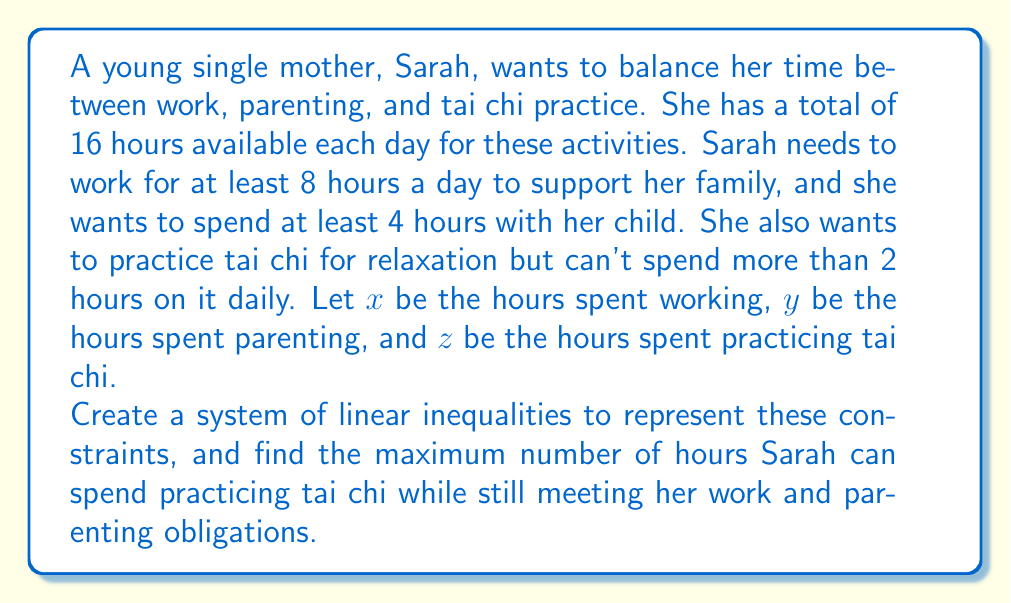Could you help me with this problem? Let's approach this problem step by step:

1. First, we need to set up the system of linear inequalities based on the given information:

   a) Total available time: $x + y + z = 16$
   b) Minimum work time: $x \geq 8$
   c) Minimum parenting time: $y \geq 4$
   d) Maximum tai chi time: $0 \leq z \leq 2$

2. Our goal is to maximize $z$, the time spent on tai chi, while satisfying all constraints.

3. From the total available time equation, we can express $z$ in terms of $x$ and $y$:
   $z = 16 - x - y$

4. Substituting this into the tai chi time constraint:
   $0 \leq 16 - x - y \leq 2$

5. This gives us two more inequalities:
   $16 - x - y \geq 0$ and $16 - x - y \leq 2$

6. Rearranging these:
   $x + y \leq 16$ and $x + y \geq 14$

7. Combining all our constraints:
   $$\begin{cases}
   x \geq 8 \\
   y \geq 4 \\
   14 \leq x + y \leq 16
   \end{cases}$$

8. To maximize $z$, we need to minimize $x + y$ while still satisfying all constraints.

9. The minimum possible value for $x + y$ that satisfies all constraints is 14, which occurs when $x = 8$ and $y = 6$.

10. Therefore, the maximum value for $z$ is:
    $z = 16 - x - y = 16 - 8 - 6 = 2$

This solution satisfies all constraints: Sarah works for 8 hours (minimum required), spends 6 hours parenting (more than the 4-hour minimum), and can practice tai chi for 2 hours (maximum allowed).
Answer: The maximum time Sarah can spend practicing tai chi while meeting her work and parenting obligations is 2 hours. 